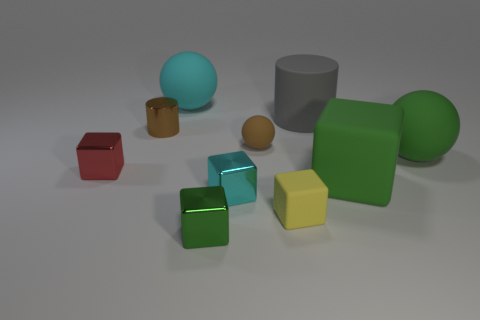Is there a red block that has the same size as the cyan rubber object?
Ensure brevity in your answer.  No. There is a yellow rubber thing; is it the same shape as the big green thing to the right of the big rubber cube?
Provide a short and direct response. No. How many blocks are big purple metallic objects or tiny cyan metal things?
Provide a short and direct response. 1. The small metal cylinder is what color?
Offer a very short reply. Brown. Is the number of small red blocks greater than the number of small rubber cylinders?
Offer a terse response. Yes. What number of things are either green balls in front of the large gray object or big matte balls?
Your answer should be very brief. 2. Do the large gray cylinder and the red block have the same material?
Your response must be concise. No. What is the size of the brown object that is the same shape as the big gray object?
Give a very brief answer. Small. Is the shape of the big thing that is to the left of the brown matte thing the same as the green object on the right side of the big matte block?
Make the answer very short. Yes. There is a brown matte object; does it have the same size as the metallic object that is on the left side of the brown cylinder?
Ensure brevity in your answer.  Yes. 